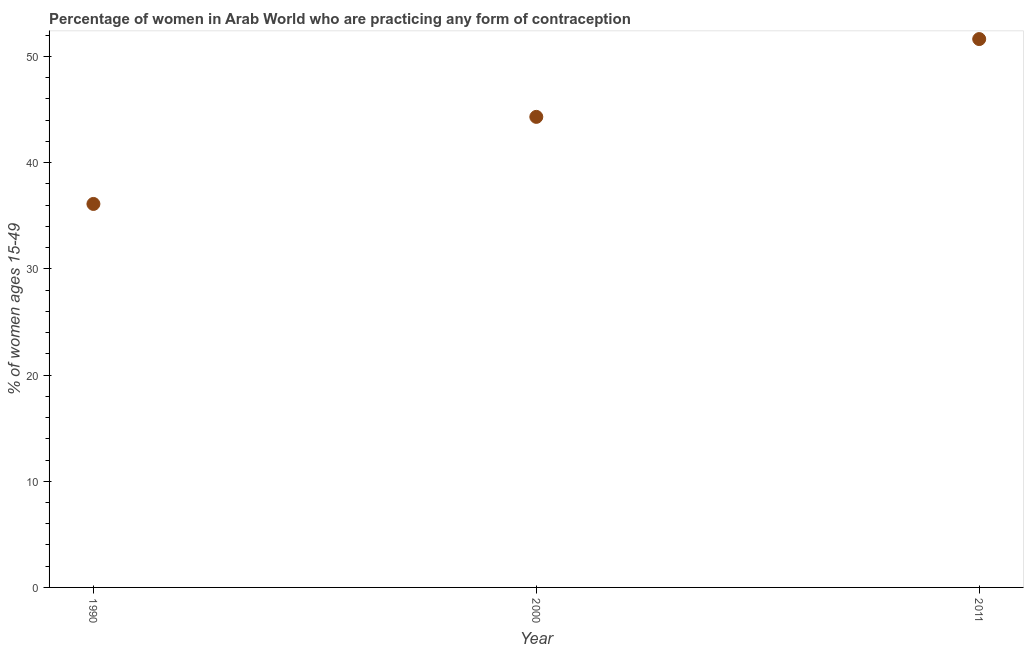What is the contraceptive prevalence in 2000?
Keep it short and to the point. 44.32. Across all years, what is the maximum contraceptive prevalence?
Offer a very short reply. 51.64. Across all years, what is the minimum contraceptive prevalence?
Provide a short and direct response. 36.11. In which year was the contraceptive prevalence maximum?
Provide a short and direct response. 2011. In which year was the contraceptive prevalence minimum?
Keep it short and to the point. 1990. What is the sum of the contraceptive prevalence?
Keep it short and to the point. 132.07. What is the difference between the contraceptive prevalence in 2000 and 2011?
Ensure brevity in your answer.  -7.33. What is the average contraceptive prevalence per year?
Ensure brevity in your answer.  44.02. What is the median contraceptive prevalence?
Make the answer very short. 44.32. Do a majority of the years between 1990 and 2011 (inclusive) have contraceptive prevalence greater than 26 %?
Keep it short and to the point. Yes. What is the ratio of the contraceptive prevalence in 1990 to that in 2000?
Keep it short and to the point. 0.81. What is the difference between the highest and the second highest contraceptive prevalence?
Keep it short and to the point. 7.33. What is the difference between the highest and the lowest contraceptive prevalence?
Your answer should be very brief. 15.53. Does the contraceptive prevalence monotonically increase over the years?
Offer a terse response. Yes. How many years are there in the graph?
Provide a short and direct response. 3. What is the difference between two consecutive major ticks on the Y-axis?
Provide a short and direct response. 10. Are the values on the major ticks of Y-axis written in scientific E-notation?
Provide a short and direct response. No. What is the title of the graph?
Your answer should be very brief. Percentage of women in Arab World who are practicing any form of contraception. What is the label or title of the X-axis?
Your answer should be compact. Year. What is the label or title of the Y-axis?
Keep it short and to the point. % of women ages 15-49. What is the % of women ages 15-49 in 1990?
Give a very brief answer. 36.11. What is the % of women ages 15-49 in 2000?
Offer a very short reply. 44.32. What is the % of women ages 15-49 in 2011?
Ensure brevity in your answer.  51.64. What is the difference between the % of women ages 15-49 in 1990 and 2000?
Provide a short and direct response. -8.2. What is the difference between the % of women ages 15-49 in 1990 and 2011?
Provide a short and direct response. -15.53. What is the difference between the % of women ages 15-49 in 2000 and 2011?
Offer a terse response. -7.33. What is the ratio of the % of women ages 15-49 in 1990 to that in 2000?
Provide a short and direct response. 0.81. What is the ratio of the % of women ages 15-49 in 1990 to that in 2011?
Provide a succinct answer. 0.7. What is the ratio of the % of women ages 15-49 in 2000 to that in 2011?
Make the answer very short. 0.86. 